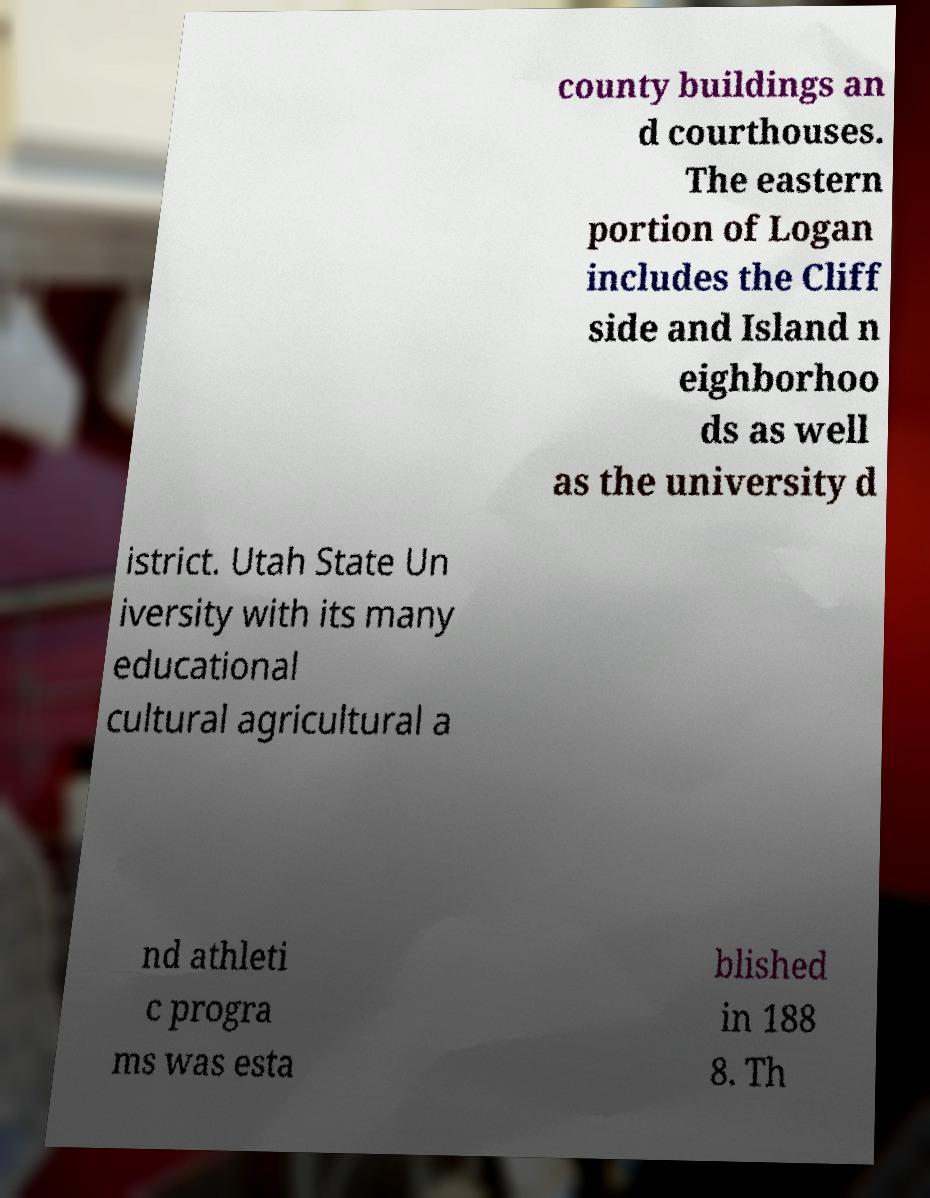There's text embedded in this image that I need extracted. Can you transcribe it verbatim? county buildings an d courthouses. The eastern portion of Logan includes the Cliff side and Island n eighborhoo ds as well as the university d istrict. Utah State Un iversity with its many educational cultural agricultural a nd athleti c progra ms was esta blished in 188 8. Th 